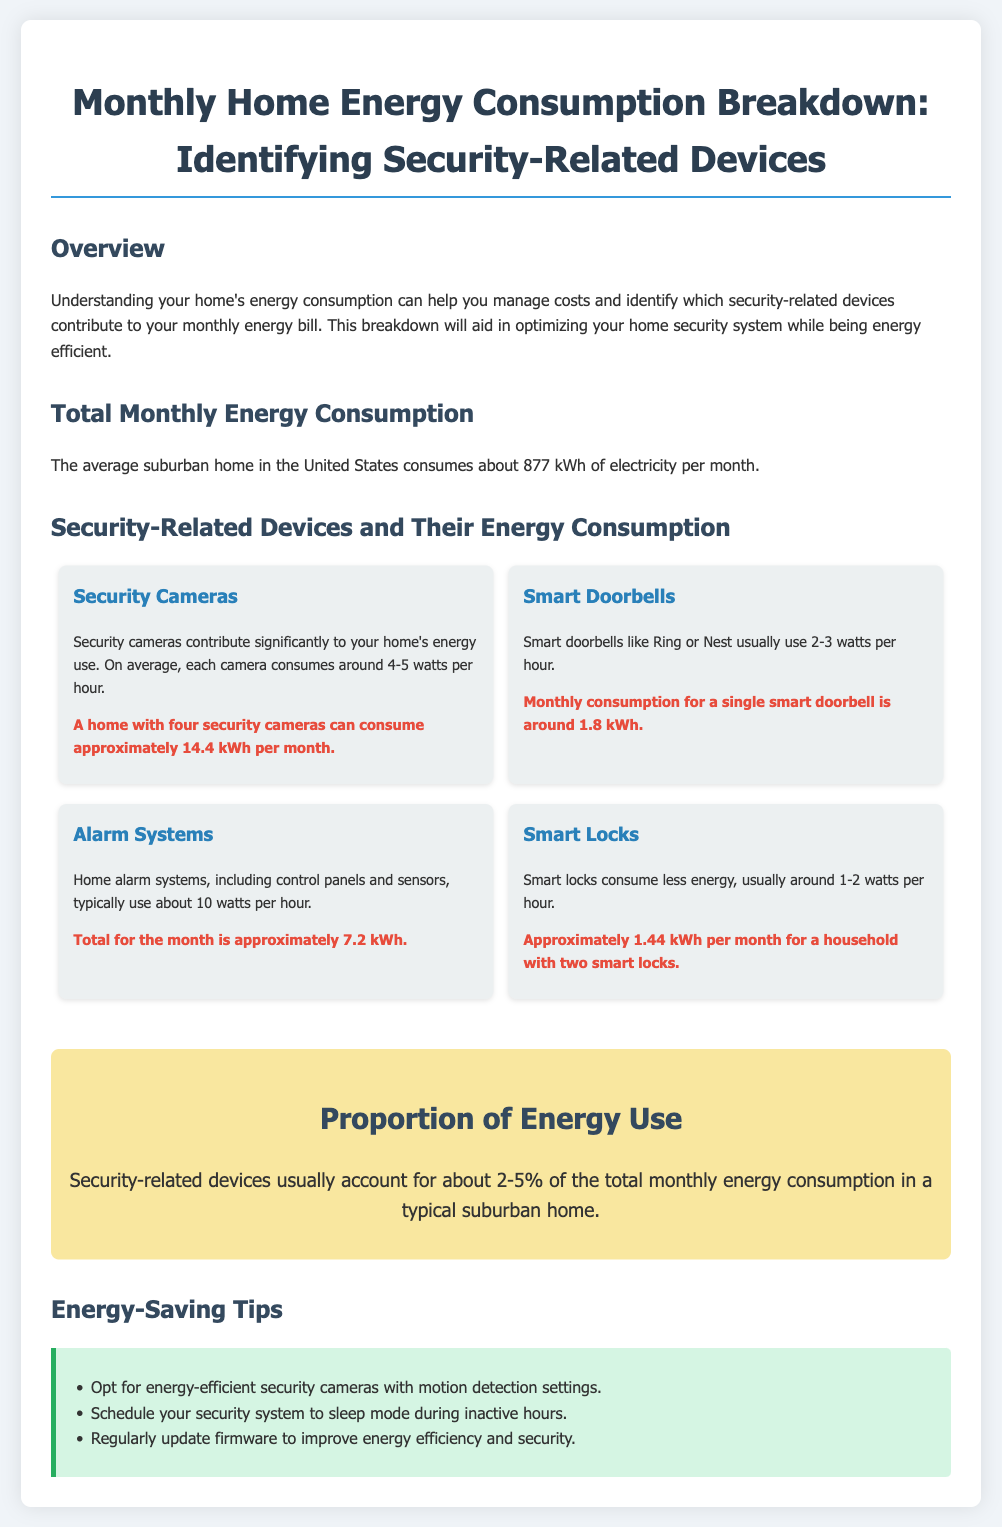What is the average electricity consumption of a suburban home? The document states that the average suburban home in the United States consumes about 877 kWh of electricity per month.
Answer: 877 kWh How much energy do security cameras consume per month? The document specifies that a home with four security cameras can consume approximately 14.4 kWh per month.
Answer: 14.4 kWh What is the monthly energy consumption for a single smart doorbell? According to the document, the monthly consumption for a single smart doorbell is around 1.8 kWh.
Answer: 1.8 kWh What percent of total monthly energy consumption do security-related devices account for? The document mentions security-related devices usually account for about 2-5% of the total monthly energy consumption in a typical suburban home.
Answer: 2-5% How much energy do alarm systems consume per month? The document notes that the total for alarm systems is approximately 7.2 kWh per month.
Answer: 7.2 kWh What is one energy-saving tip provided in the document? The document includes several tips such as opting for energy-efficient security cameras with motion detection settings.
Answer: Opt for energy-efficient security cameras with motion detection settings How much energy do smart locks consume monthly for two locks? The document states that approximately 1.44 kWh per month for a household with two smart locks.
Answer: 1.44 kWh What is the typical energy consumption of smart doorbells per hour? The document indicates that smart doorbells usually use 2-3 watts per hour.
Answer: 2-3 watts What is the primary purpose of this infographic? The document explains that understanding home energy consumption can help manage costs and identify security-related devices contributing to the energy bill.
Answer: Manage costs and identify security-related devices 